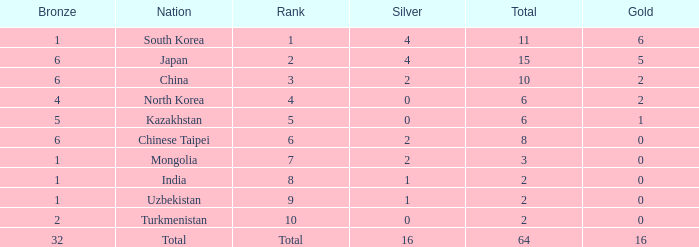What's the biggest Bronze that has less than 0 Silvers? None. Could you parse the entire table as a dict? {'header': ['Bronze', 'Nation', 'Rank', 'Silver', 'Total', 'Gold'], 'rows': [['1', 'South Korea', '1', '4', '11', '6'], ['6', 'Japan', '2', '4', '15', '5'], ['6', 'China', '3', '2', '10', '2'], ['4', 'North Korea', '4', '0', '6', '2'], ['5', 'Kazakhstan', '5', '0', '6', '1'], ['6', 'Chinese Taipei', '6', '2', '8', '0'], ['1', 'Mongolia', '7', '2', '3', '0'], ['1', 'India', '8', '1', '2', '0'], ['1', 'Uzbekistan', '9', '1', '2', '0'], ['2', 'Turkmenistan', '10', '0', '2', '0'], ['32', 'Total', 'Total', '16', '64', '16']]} 